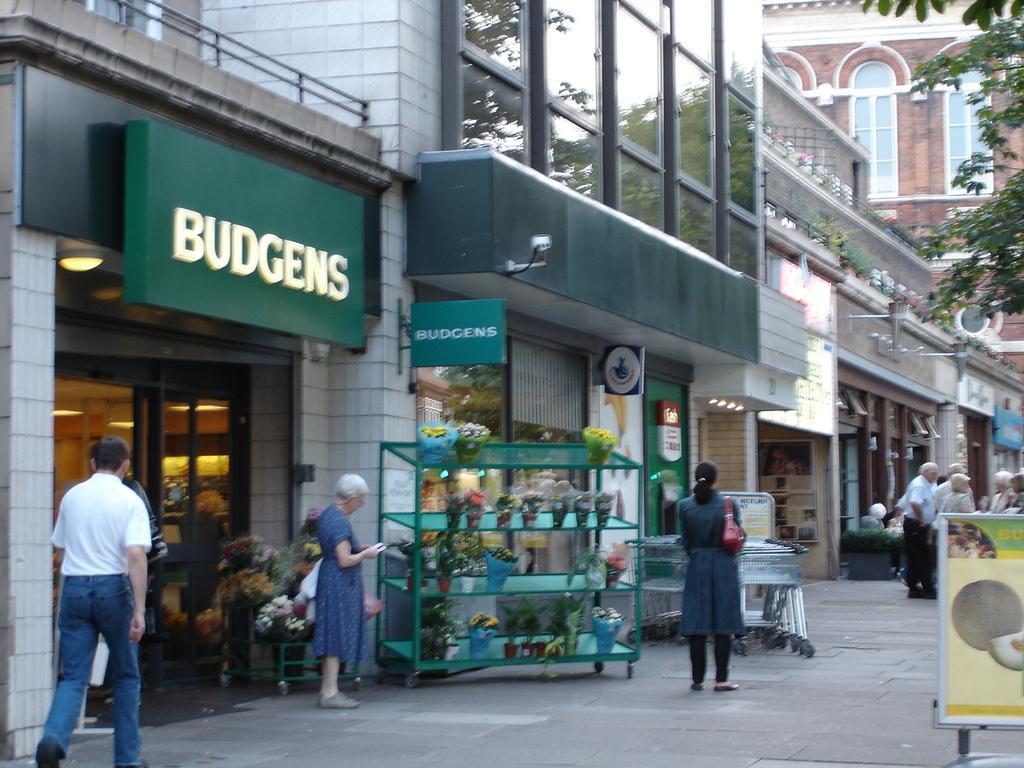In one or two sentences, can you explain what this image depicts? In this image I can see group of people some are standing and some are walking, in front I can see few bouquets and I can see few buildings in white and brown color, and trees in green color. I can also see a green color board attached to the building. 